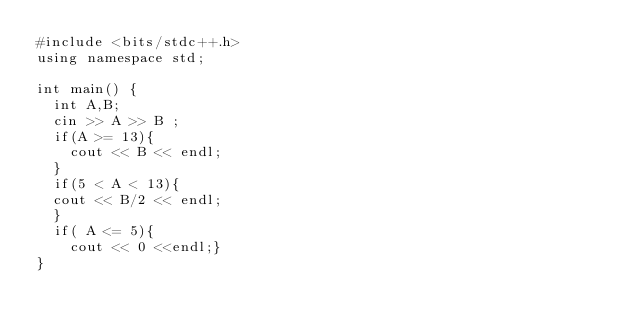<code> <loc_0><loc_0><loc_500><loc_500><_C++_>#include <bits/stdc++.h>
using namespace std;

int main() {
  int A,B;
  cin >> A >> B ;
  if(A >= 13){
    cout << B << endl;
  }
  if(5 < A < 13){
  cout << B/2 << endl;
  }
  if( A <= 5){
    cout << 0 <<endl;}
}
</code> 